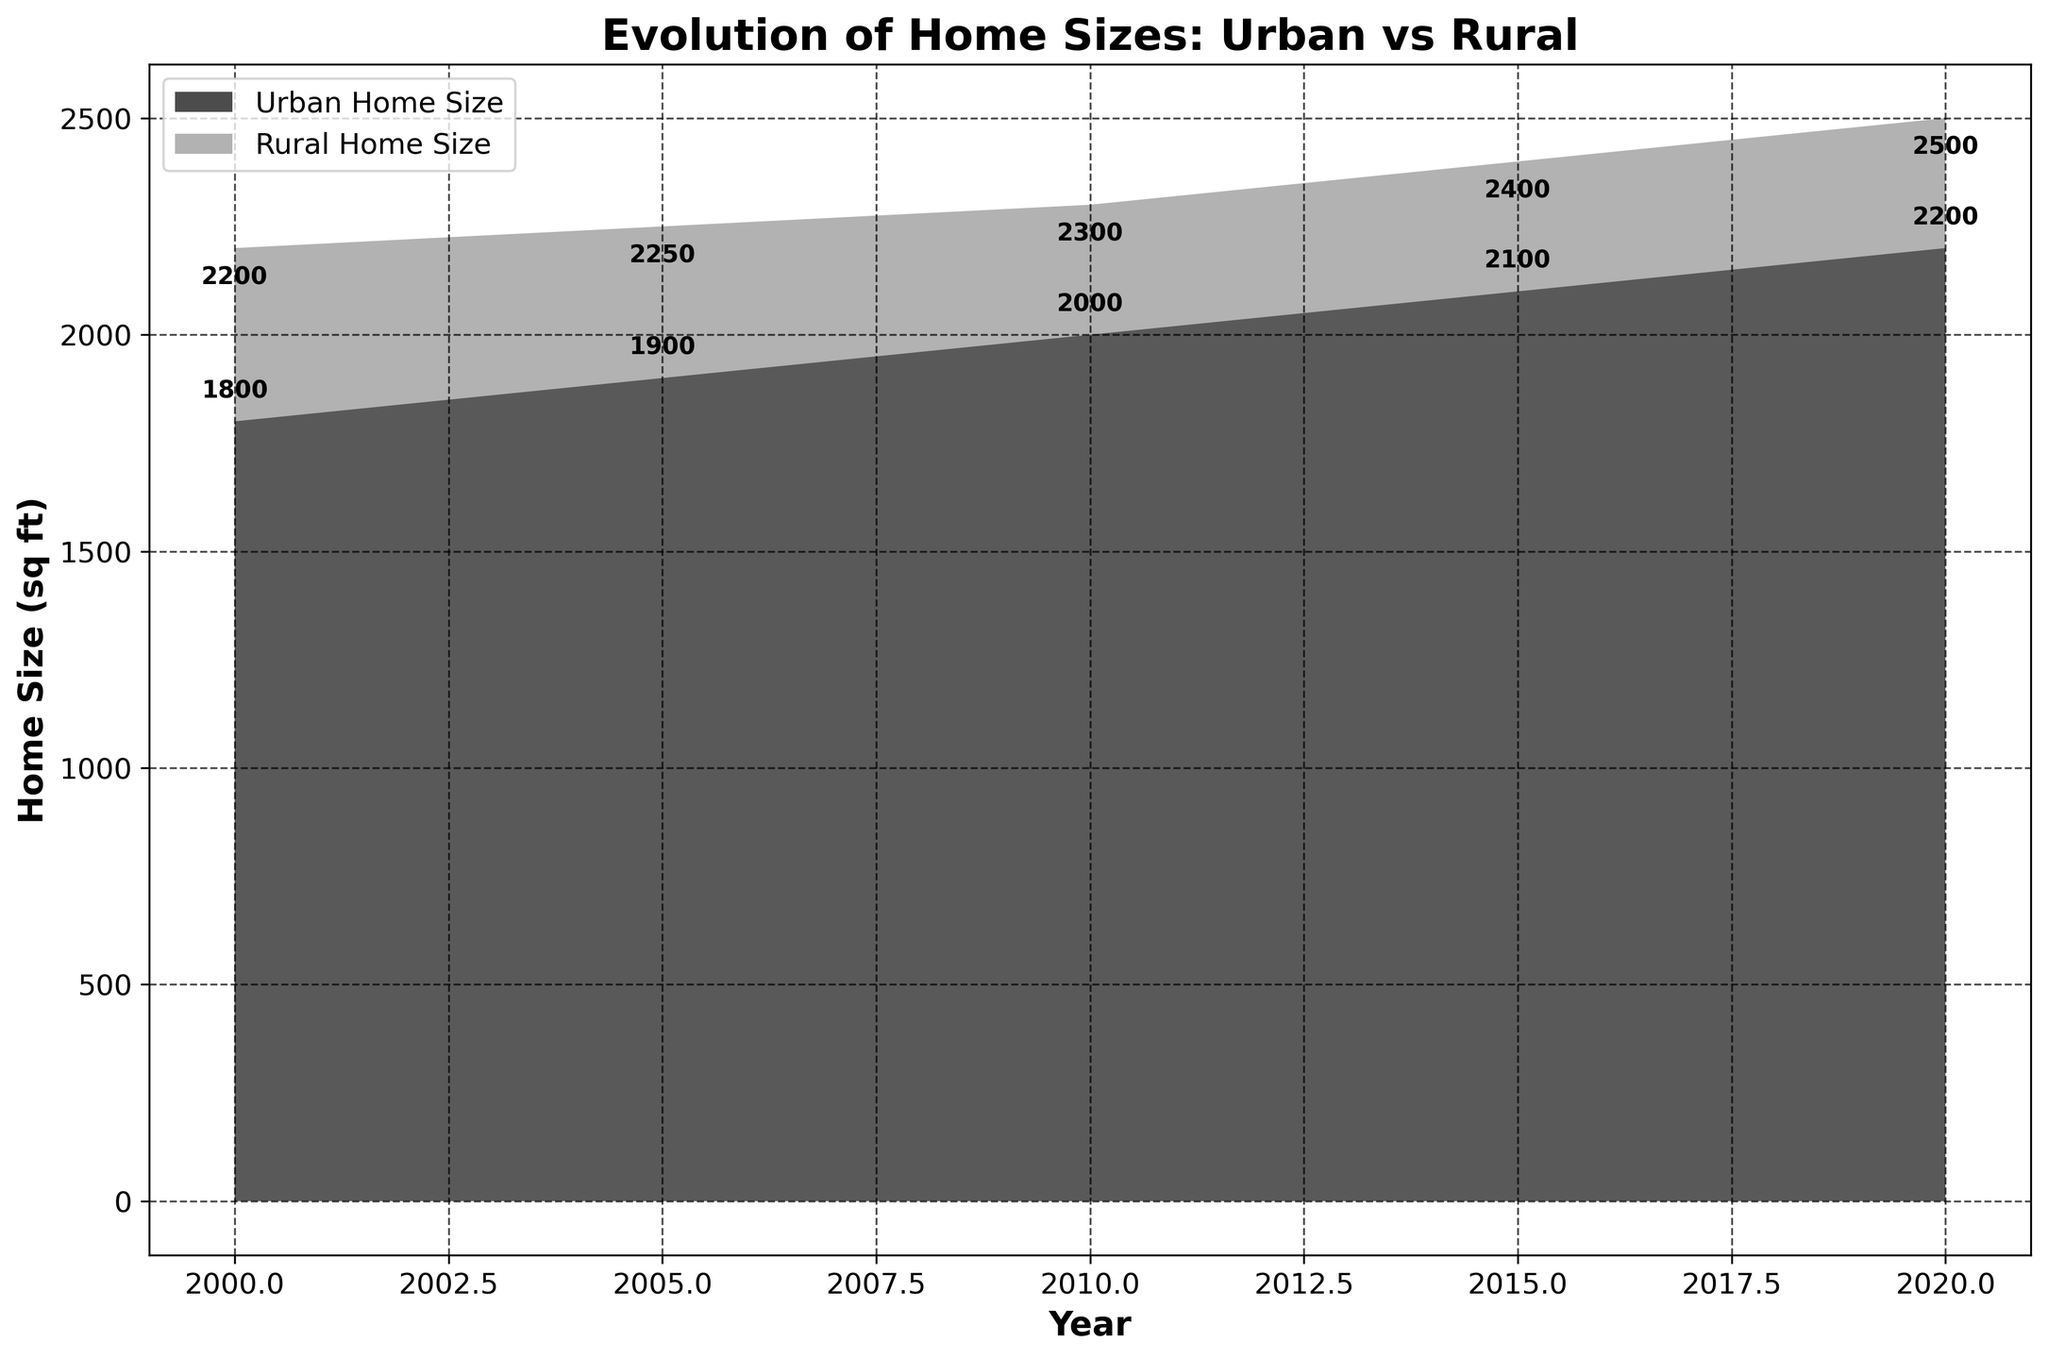Which year has the largest urban home size? Look at the area chart and find the year where the urban area has the highest value. This occurs at the rightmost point on the urban area, which is the year 2020.
Answer: 2020 What's the difference between urban and rural home sizes in 2010? In 2010, the urban home size is 2000 sqft, while the rural home size is 2300 sqft. The difference is calculated as 2300 - 2000.
Answer: 300 sqft How has the urban home size changed from 2000 to 2020? Observe the changes in the urban home size line from 2000 (1800 sqft) to 2020 (2200 sqft). The increase over the years is 2200 - 1800.
Answer: Increased by 400 sqft Which area had a more significant increase in home size from 2005 to 2015? Compare the increase in home sizes in both areas from 2005 to 2015. Urban size increased from 1900 sqft to 2100 sqft (2100 - 1900) = 200 sqft. Rural size increased from 2250 sqft to 2400 sqft (2400 - 2250) = 150 sqft.
Answer: Urban area In which year were urban and rural home sizes closest in value? Find the years where the gap between urban and rural home sizes is minimal by comparing their distances each year. The smallest difference is in the year 2000 with a difference of (2200 - 1800).
Answer: 2000 What specific baby-proofing challenge appears in rural homes in 2015? Check the data table for 2015 under the "Baby_Proofing_Challenges_Rural" column.
Answer: Presence of large animals Based on the figure, what trend can you observe about urban home sizes over the years? Analyze the pattern of the urban home size line from 2000 to 2020. It shows a steady increase in urban home sizes.
Answer: Increasing trend What solutions are common in urban areas for high traffic and multifunctional rooms? Look at the data in the "Common_Solutions_Urban" column for the relevant years. For busy high-traffic areas in 2010, solutions include stair gates and door locks. For multifunctional rooms in 2015, solutions include flexible room dividers.
Answer: Stair gates, door locks, flexible room dividers In what year did rural home sizes hit 2300 sqft? Identify the year on the chart where the rural home size line first reaches 2300 sqft. This milestone occurs in 2010.
Answer: 2010 Which has a more significant challenge with limited space for play areas, urban or rural homes? Refer to the data table where "Limited_Space_for_Play_Areas" is listed under "Baby_Proofing_Challenges". It is noted for urban areas in 2005.
Answer: Urban homes 